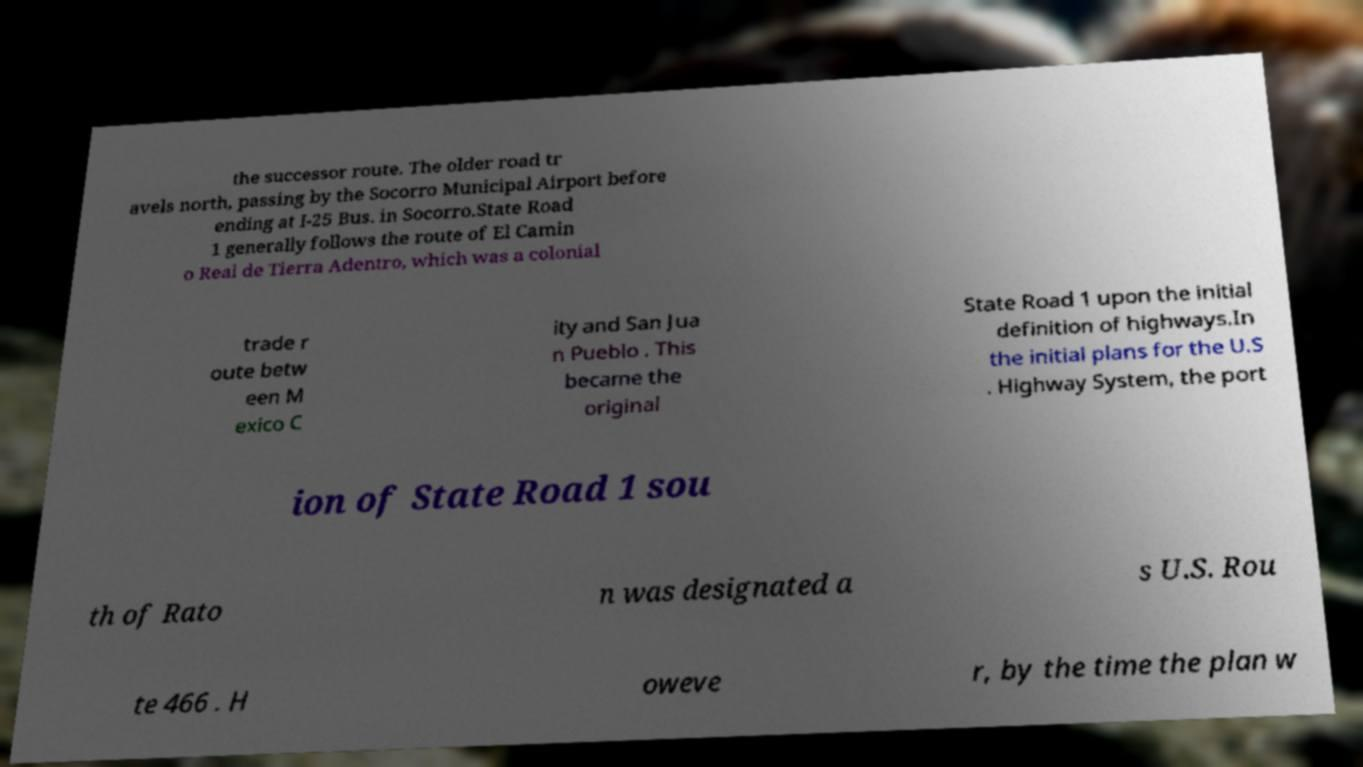What messages or text are displayed in this image? I need them in a readable, typed format. the successor route. The older road tr avels north, passing by the Socorro Municipal Airport before ending at I-25 Bus. in Socorro.State Road 1 generally follows the route of El Camin o Real de Tierra Adentro, which was a colonial trade r oute betw een M exico C ity and San Jua n Pueblo . This became the original State Road 1 upon the initial definition of highways.In the initial plans for the U.S . Highway System, the port ion of State Road 1 sou th of Rato n was designated a s U.S. Rou te 466 . H oweve r, by the time the plan w 